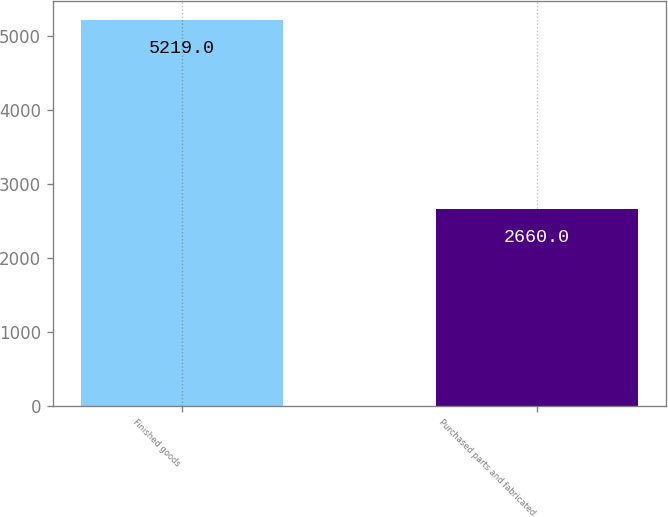<chart> <loc_0><loc_0><loc_500><loc_500><bar_chart><fcel>Finished goods<fcel>Purchased parts and fabricated<nl><fcel>5219<fcel>2660<nl></chart> 